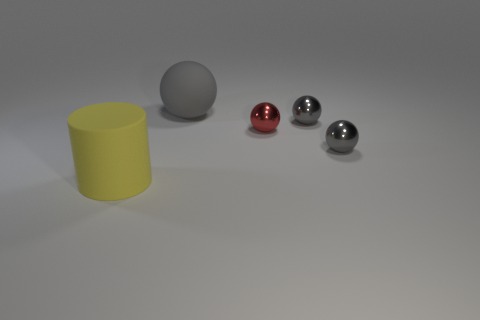What number of shiny objects have the same color as the large matte sphere?
Make the answer very short. 2. Is the size of the yellow matte cylinder the same as the red thing?
Keep it short and to the point. No. There is a object right of the tiny object behind the red thing; what size is it?
Provide a short and direct response. Small. There is a matte sphere; is it the same color as the metal object behind the small red metal object?
Ensure brevity in your answer.  Yes. Are there any gray spheres of the same size as the matte cylinder?
Give a very brief answer. Yes. There is a red sphere that is in front of the big gray rubber thing; what is its size?
Your response must be concise. Small. Is there a tiny red metallic object that is behind the thing that is to the left of the big gray sphere?
Your response must be concise. Yes. How many other things are the same shape as the red shiny object?
Make the answer very short. 3. Is the shape of the gray rubber object the same as the small red metallic thing?
Your response must be concise. Yes. What color is the object that is in front of the small red metal sphere and behind the yellow cylinder?
Your response must be concise. Gray. 